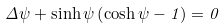Convert formula to latex. <formula><loc_0><loc_0><loc_500><loc_500>\Delta \psi + \sinh \psi \left ( \cosh \psi - 1 \right ) = 0</formula> 